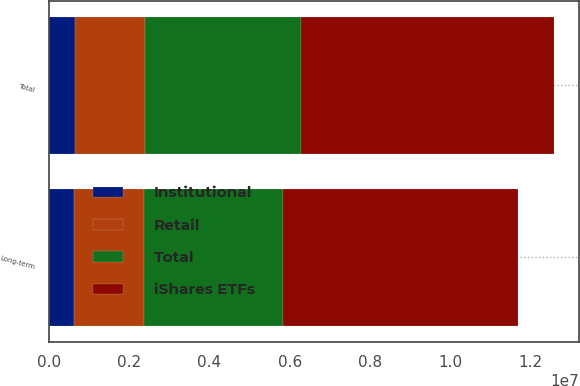<chart> <loc_0><loc_0><loc_500><loc_500><stacked_bar_chart><ecel><fcel>Long-term<fcel>Total<nl><fcel>Institutional<fcel>628377<fcel>652731<nl><fcel>Retail<fcel>1.75224e+06<fcel>1.75224e+06<nl><fcel>Total<fcel>3.45612e+06<fcel>3.88322e+06<nl><fcel>iShares ETFs<fcel>5.83673e+06<fcel>6.2882e+06<nl></chart> 